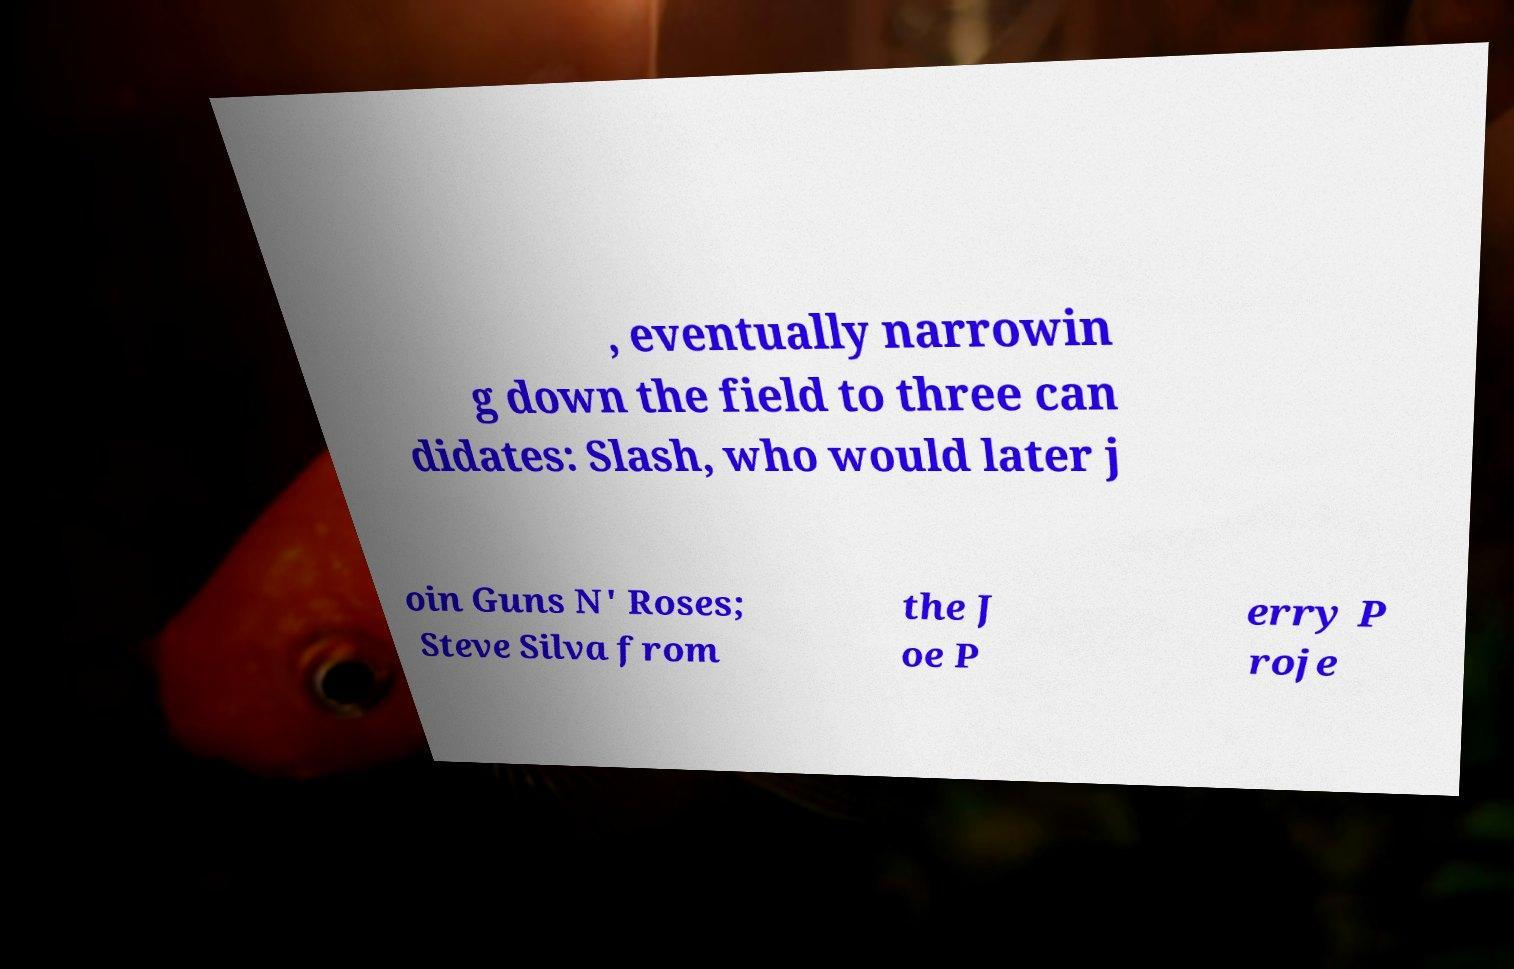Could you assist in decoding the text presented in this image and type it out clearly? , eventually narrowin g down the field to three can didates: Slash, who would later j oin Guns N' Roses; Steve Silva from the J oe P erry P roje 